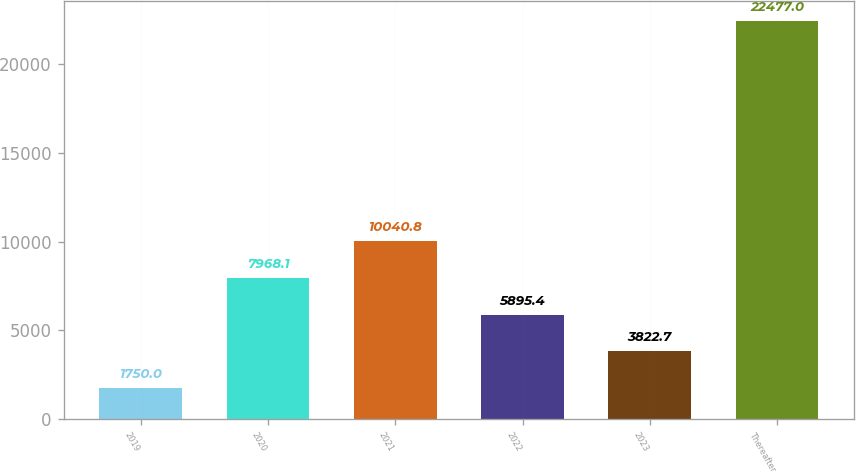Convert chart. <chart><loc_0><loc_0><loc_500><loc_500><bar_chart><fcel>2019<fcel>2020<fcel>2021<fcel>2022<fcel>2023<fcel>Thereafter<nl><fcel>1750<fcel>7968.1<fcel>10040.8<fcel>5895.4<fcel>3822.7<fcel>22477<nl></chart> 